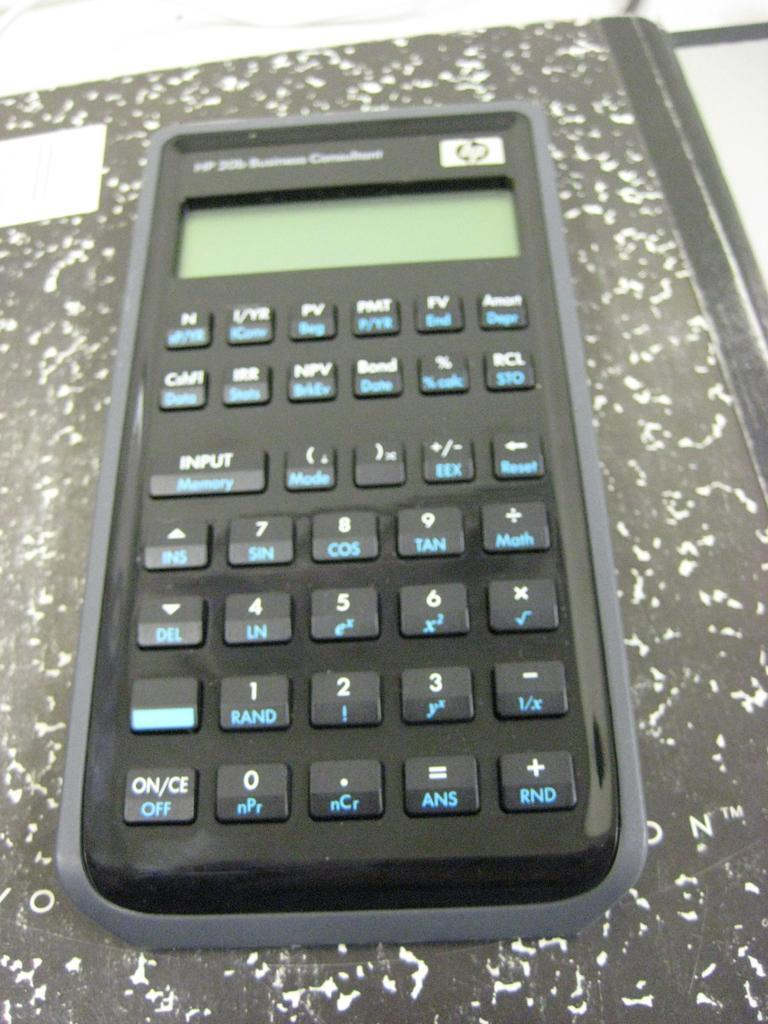<image>
Create a compact narrative representing the image presented. A calculator has white ON text and blue OFF text. 